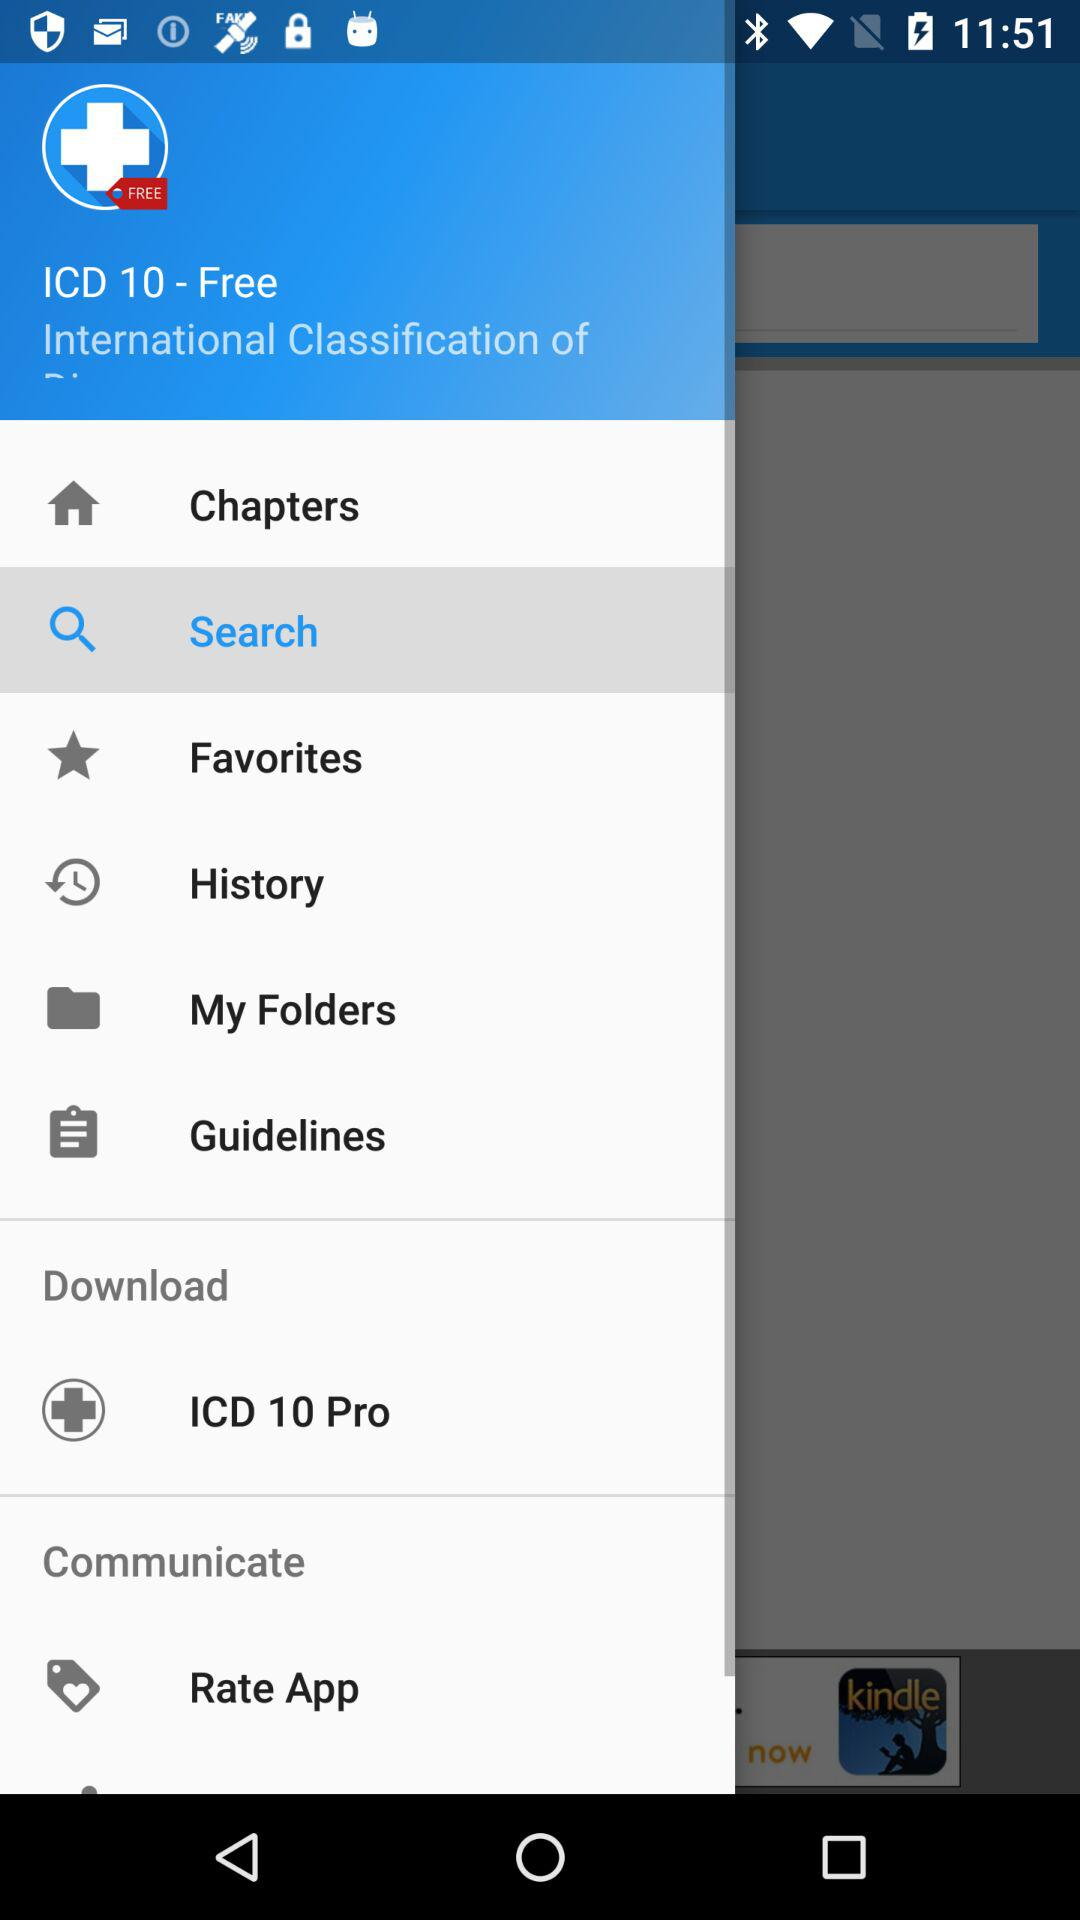What is the application name? The application name is "ICD 10". 